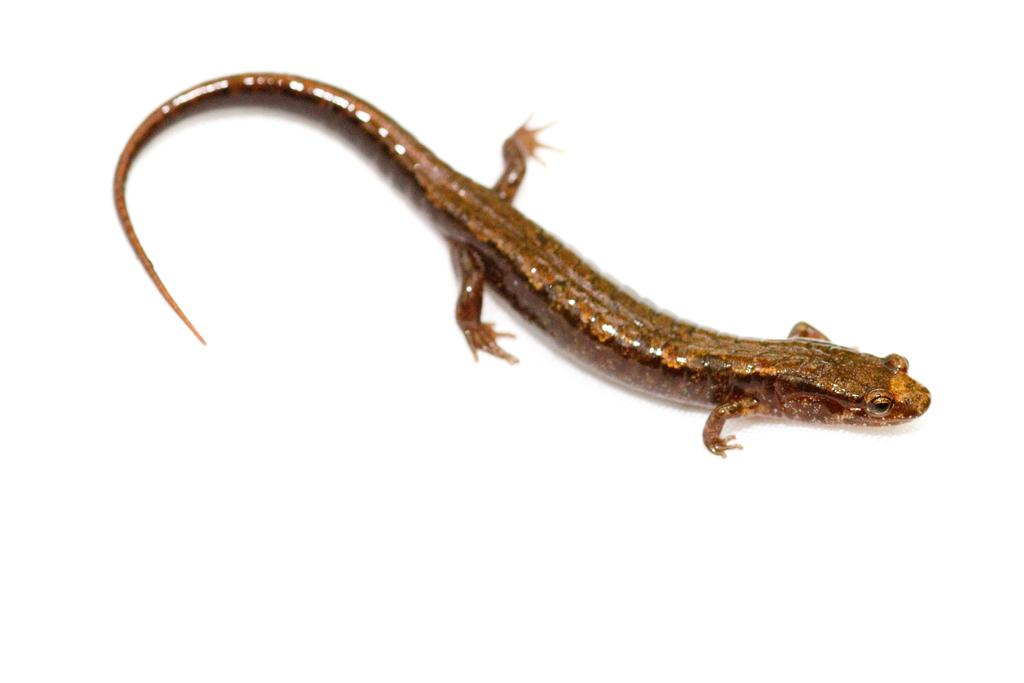What type of animal is in the image? There is a lizard in the image. What color is the lizard? The lizard is brown in color. Can you describe the color of the lizard in more detail? The lizard has a pale brown color. What account does the lizard have on social media? There is no information about the lizard having a social media account in the image or the provided facts. 